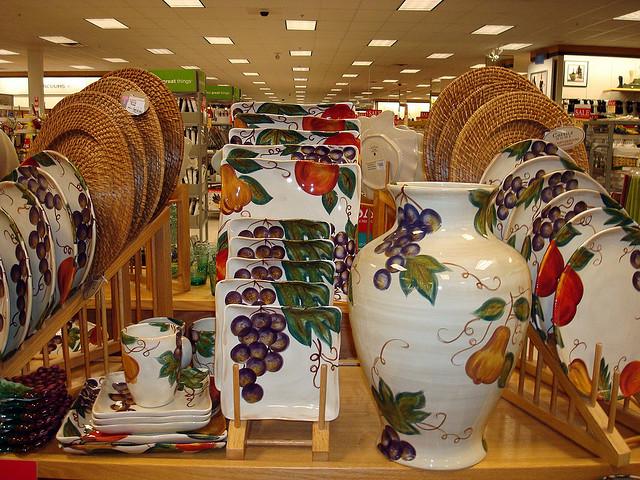Are the objects in the photo easy to break?
Short answer required. Yes. Are these items in a person's home?
Answer briefly. No. What is the decor on the plates?
Keep it brief. Fruit. 